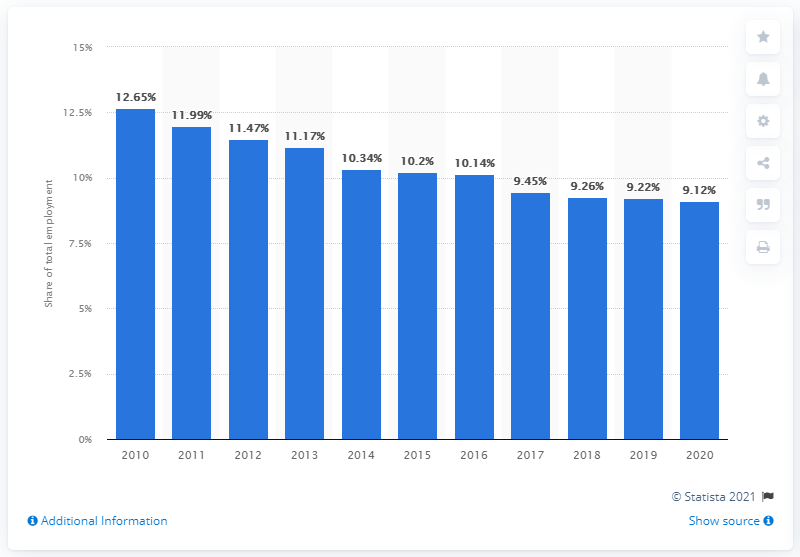Outline some significant characteristics in this image. In 2020, the agricultural sector in Brazil created approximately 9.12% of the total employment opportunities in the country. 